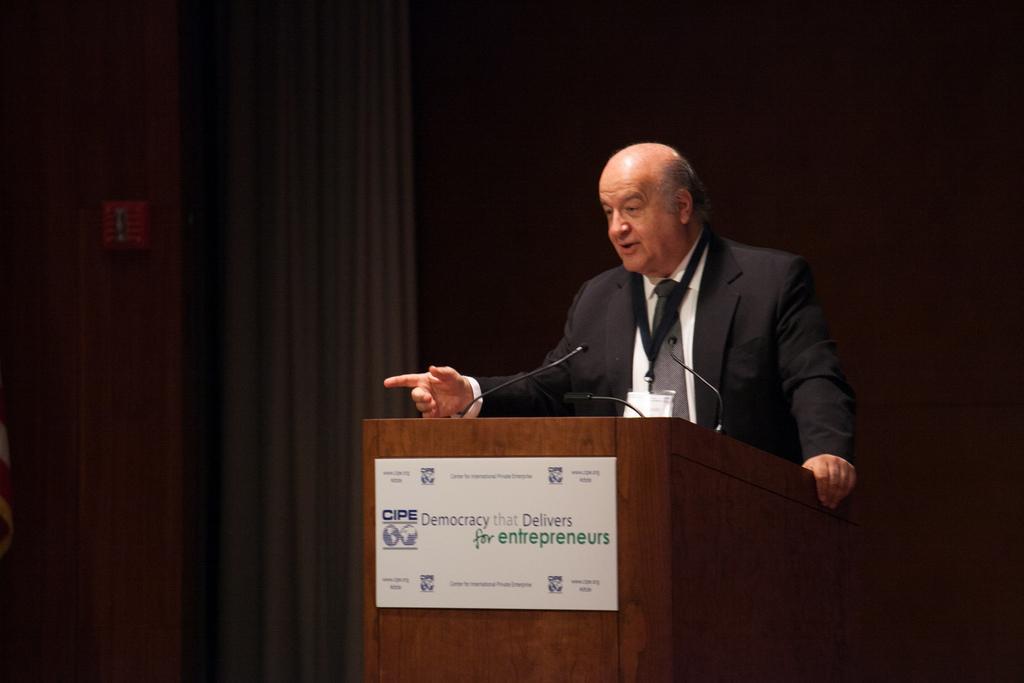Please provide a concise description of this image. In this picture I can see a man standing near the podium, there is a board, there are mikes, and in the background there is a wall and some other objects. 